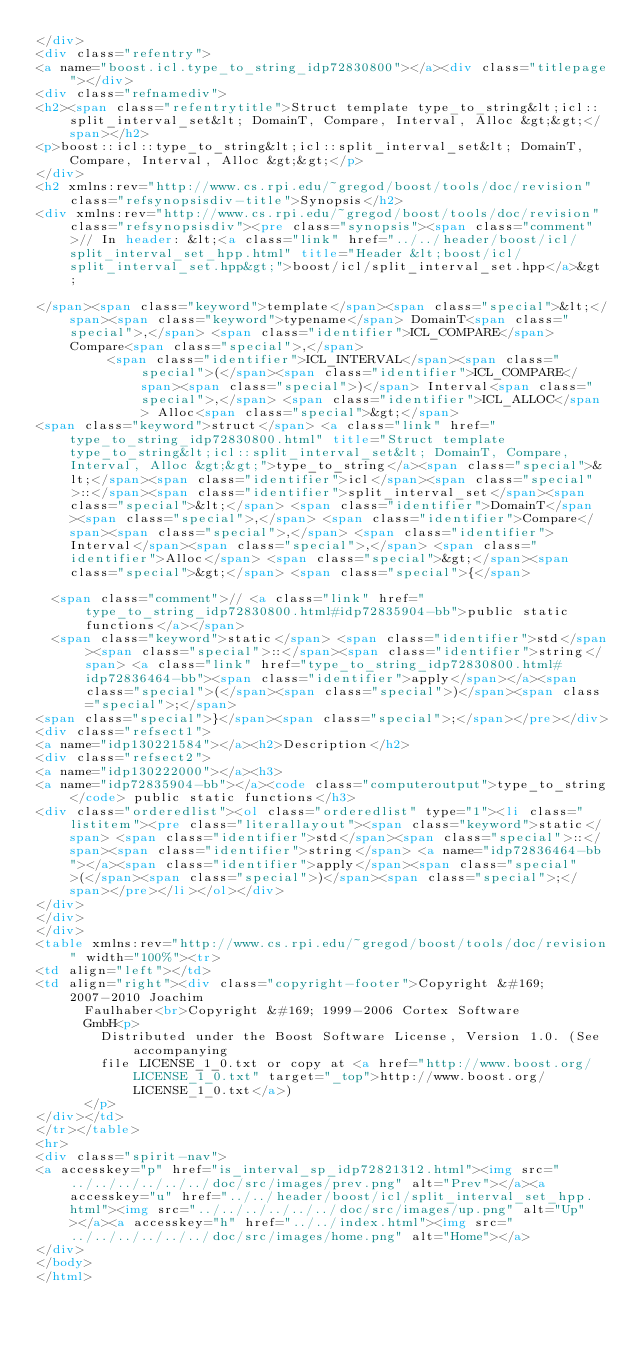Convert code to text. <code><loc_0><loc_0><loc_500><loc_500><_HTML_></div>
<div class="refentry">
<a name="boost.icl.type_to_string_idp72830800"></a><div class="titlepage"></div>
<div class="refnamediv">
<h2><span class="refentrytitle">Struct template type_to_string&lt;icl::split_interval_set&lt; DomainT, Compare, Interval, Alloc &gt;&gt;</span></h2>
<p>boost::icl::type_to_string&lt;icl::split_interval_set&lt; DomainT, Compare, Interval, Alloc &gt;&gt;</p>
</div>
<h2 xmlns:rev="http://www.cs.rpi.edu/~gregod/boost/tools/doc/revision" class="refsynopsisdiv-title">Synopsis</h2>
<div xmlns:rev="http://www.cs.rpi.edu/~gregod/boost/tools/doc/revision" class="refsynopsisdiv"><pre class="synopsis"><span class="comment">// In header: &lt;<a class="link" href="../../header/boost/icl/split_interval_set_hpp.html" title="Header &lt;boost/icl/split_interval_set.hpp&gt;">boost/icl/split_interval_set.hpp</a>&gt;

</span><span class="keyword">template</span><span class="special">&lt;</span><span class="keyword">typename</span> DomainT<span class="special">,</span> <span class="identifier">ICL_COMPARE</span> Compare<span class="special">,</span> 
         <span class="identifier">ICL_INTERVAL</span><span class="special">(</span><span class="identifier">ICL_COMPARE</span><span class="special">)</span> Interval<span class="special">,</span> <span class="identifier">ICL_ALLOC</span> Alloc<span class="special">&gt;</span> 
<span class="keyword">struct</span> <a class="link" href="type_to_string_idp72830800.html" title="Struct template type_to_string&lt;icl::split_interval_set&lt; DomainT, Compare, Interval, Alloc &gt;&gt;">type_to_string</a><span class="special">&lt;</span><span class="identifier">icl</span><span class="special">::</span><span class="identifier">split_interval_set</span><span class="special">&lt;</span> <span class="identifier">DomainT</span><span class="special">,</span> <span class="identifier">Compare</span><span class="special">,</span> <span class="identifier">Interval</span><span class="special">,</span> <span class="identifier">Alloc</span> <span class="special">&gt;</span><span class="special">&gt;</span> <span class="special">{</span>

  <span class="comment">// <a class="link" href="type_to_string_idp72830800.html#idp72835904-bb">public static functions</a></span>
  <span class="keyword">static</span> <span class="identifier">std</span><span class="special">::</span><span class="identifier">string</span> <a class="link" href="type_to_string_idp72830800.html#idp72836464-bb"><span class="identifier">apply</span></a><span class="special">(</span><span class="special">)</span><span class="special">;</span>
<span class="special">}</span><span class="special">;</span></pre></div>
<div class="refsect1">
<a name="idp130221584"></a><h2>Description</h2>
<div class="refsect2">
<a name="idp130222000"></a><h3>
<a name="idp72835904-bb"></a><code class="computeroutput">type_to_string</code> public static functions</h3>
<div class="orderedlist"><ol class="orderedlist" type="1"><li class="listitem"><pre class="literallayout"><span class="keyword">static</span> <span class="identifier">std</span><span class="special">::</span><span class="identifier">string</span> <a name="idp72836464-bb"></a><span class="identifier">apply</span><span class="special">(</span><span class="special">)</span><span class="special">;</span></pre></li></ol></div>
</div>
</div>
</div>
<table xmlns:rev="http://www.cs.rpi.edu/~gregod/boost/tools/doc/revision" width="100%"><tr>
<td align="left"></td>
<td align="right"><div class="copyright-footer">Copyright &#169; 2007-2010 Joachim
      Faulhaber<br>Copyright &#169; 1999-2006 Cortex Software
      GmbH<p>
        Distributed under the Boost Software License, Version 1.0. (See accompanying
        file LICENSE_1_0.txt or copy at <a href="http://www.boost.org/LICENSE_1_0.txt" target="_top">http://www.boost.org/LICENSE_1_0.txt</a>)
      </p>
</div></td>
</tr></table>
<hr>
<div class="spirit-nav">
<a accesskey="p" href="is_interval_sp_idp72821312.html"><img src="../../../../../../doc/src/images/prev.png" alt="Prev"></a><a accesskey="u" href="../../header/boost/icl/split_interval_set_hpp.html"><img src="../../../../../../doc/src/images/up.png" alt="Up"></a><a accesskey="h" href="../../index.html"><img src="../../../../../../doc/src/images/home.png" alt="Home"></a>
</div>
</body>
</html>
</code> 